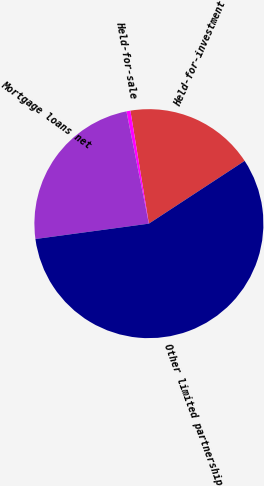<chart> <loc_0><loc_0><loc_500><loc_500><pie_chart><fcel>Held-for-investment<fcel>Held-for-sale<fcel>Mortgage loans net<fcel>Other limited partnership<nl><fcel>18.35%<fcel>0.56%<fcel>24.0%<fcel>57.09%<nl></chart> 